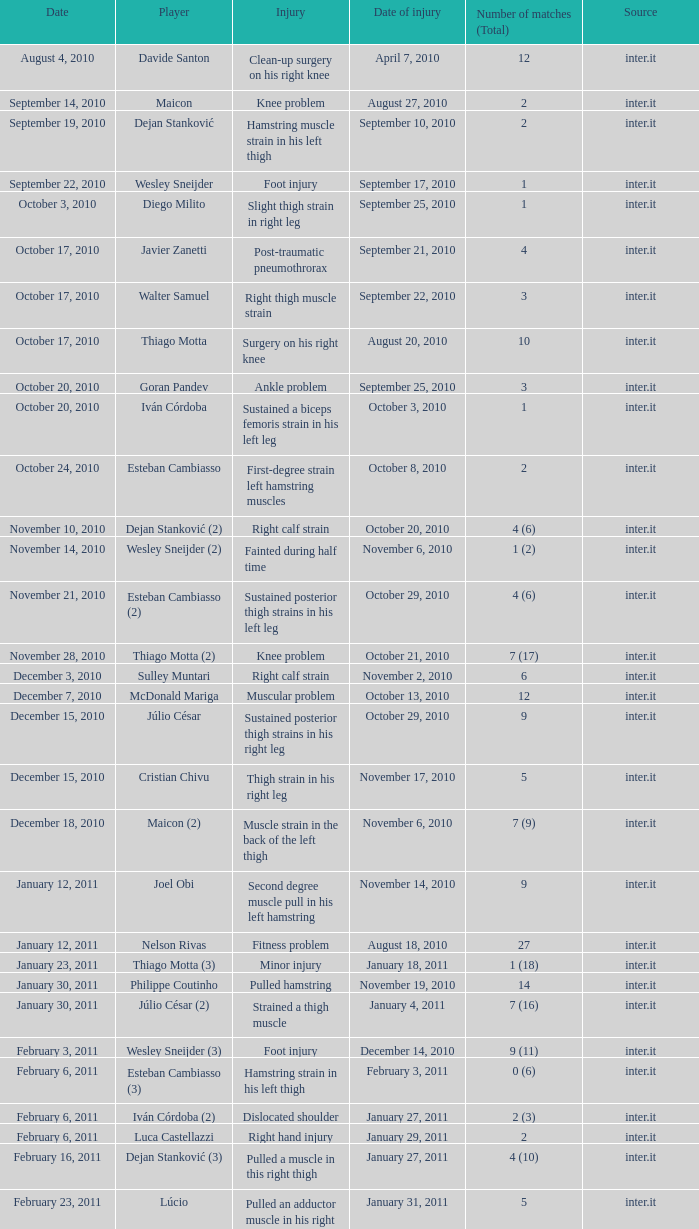What is the date of the foot injury when the total number of matches is 1? September 17, 2010. 